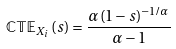<formula> <loc_0><loc_0><loc_500><loc_500>\mathbb { C T E } _ { X _ { i } } \left ( s \right ) = \frac { \alpha \left ( 1 - s \right ) ^ { - 1 / \alpha } } { \alpha - 1 }</formula> 